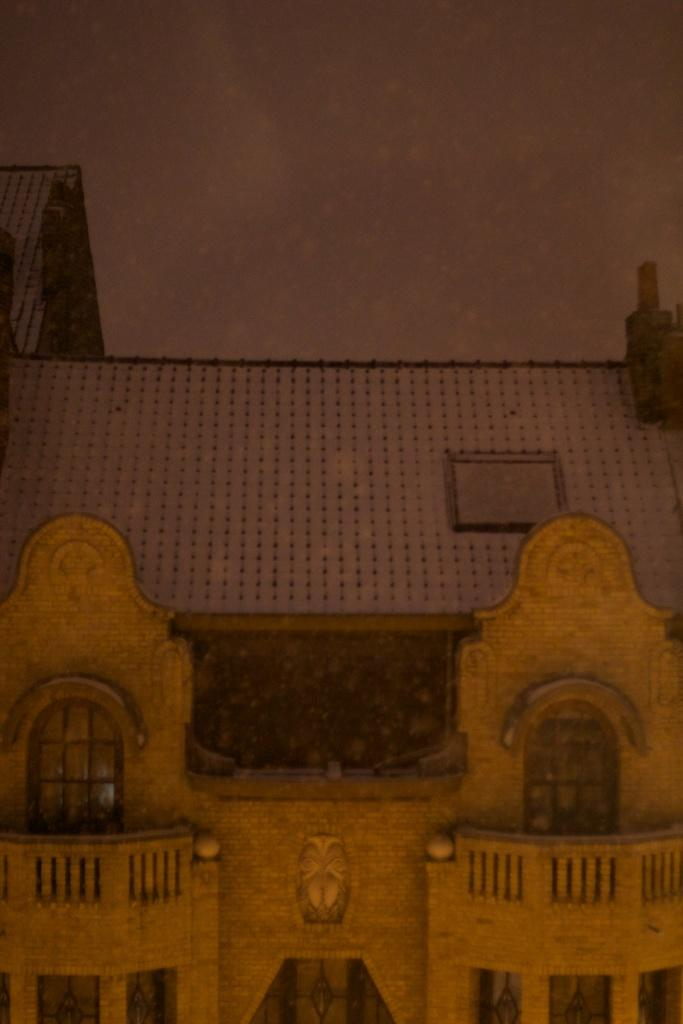What type of structure is visible in the image? There is a building in the image. How many bananas are hanging from the branch in the image? There is no banana or branch present in the image; it only features a building. 